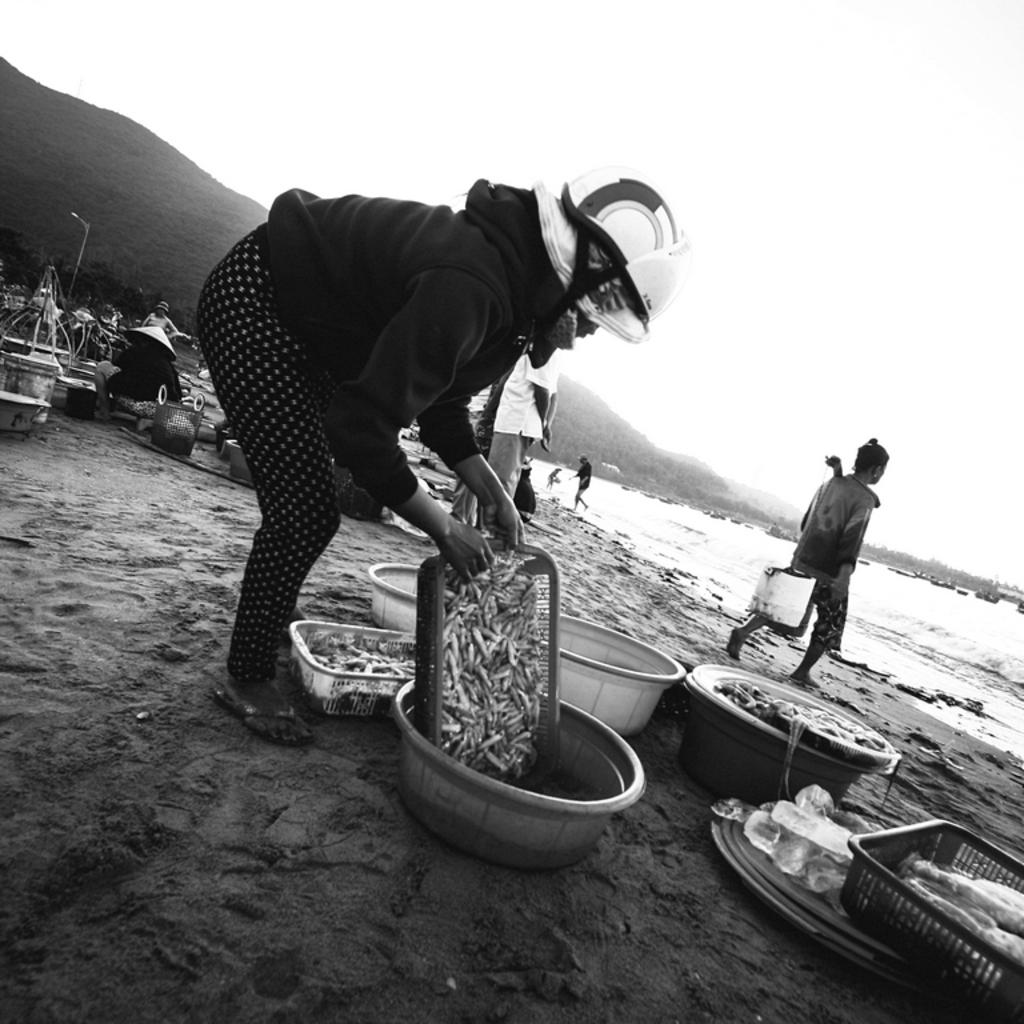What is the surface that the persons are standing on in the image? The persons are standing on the sand in the image. What can be found in the baskets that are visible? There are fishes in the baskets. What structures can be seen in the background of the image? There is a street light, a street pole, a hill, and the sea visible in the background. What part of the natural environment is visible in the image? The sky is visible in the background of the image. Can you tell me how many robins are perched on the street pole in the image? There are no robins present in the image; the focus is on the persons, fishes, and background elements. What type of cherry is being sold by the persons on the sand? There is no mention of cherries or any type of fruit being sold or present in the image. 